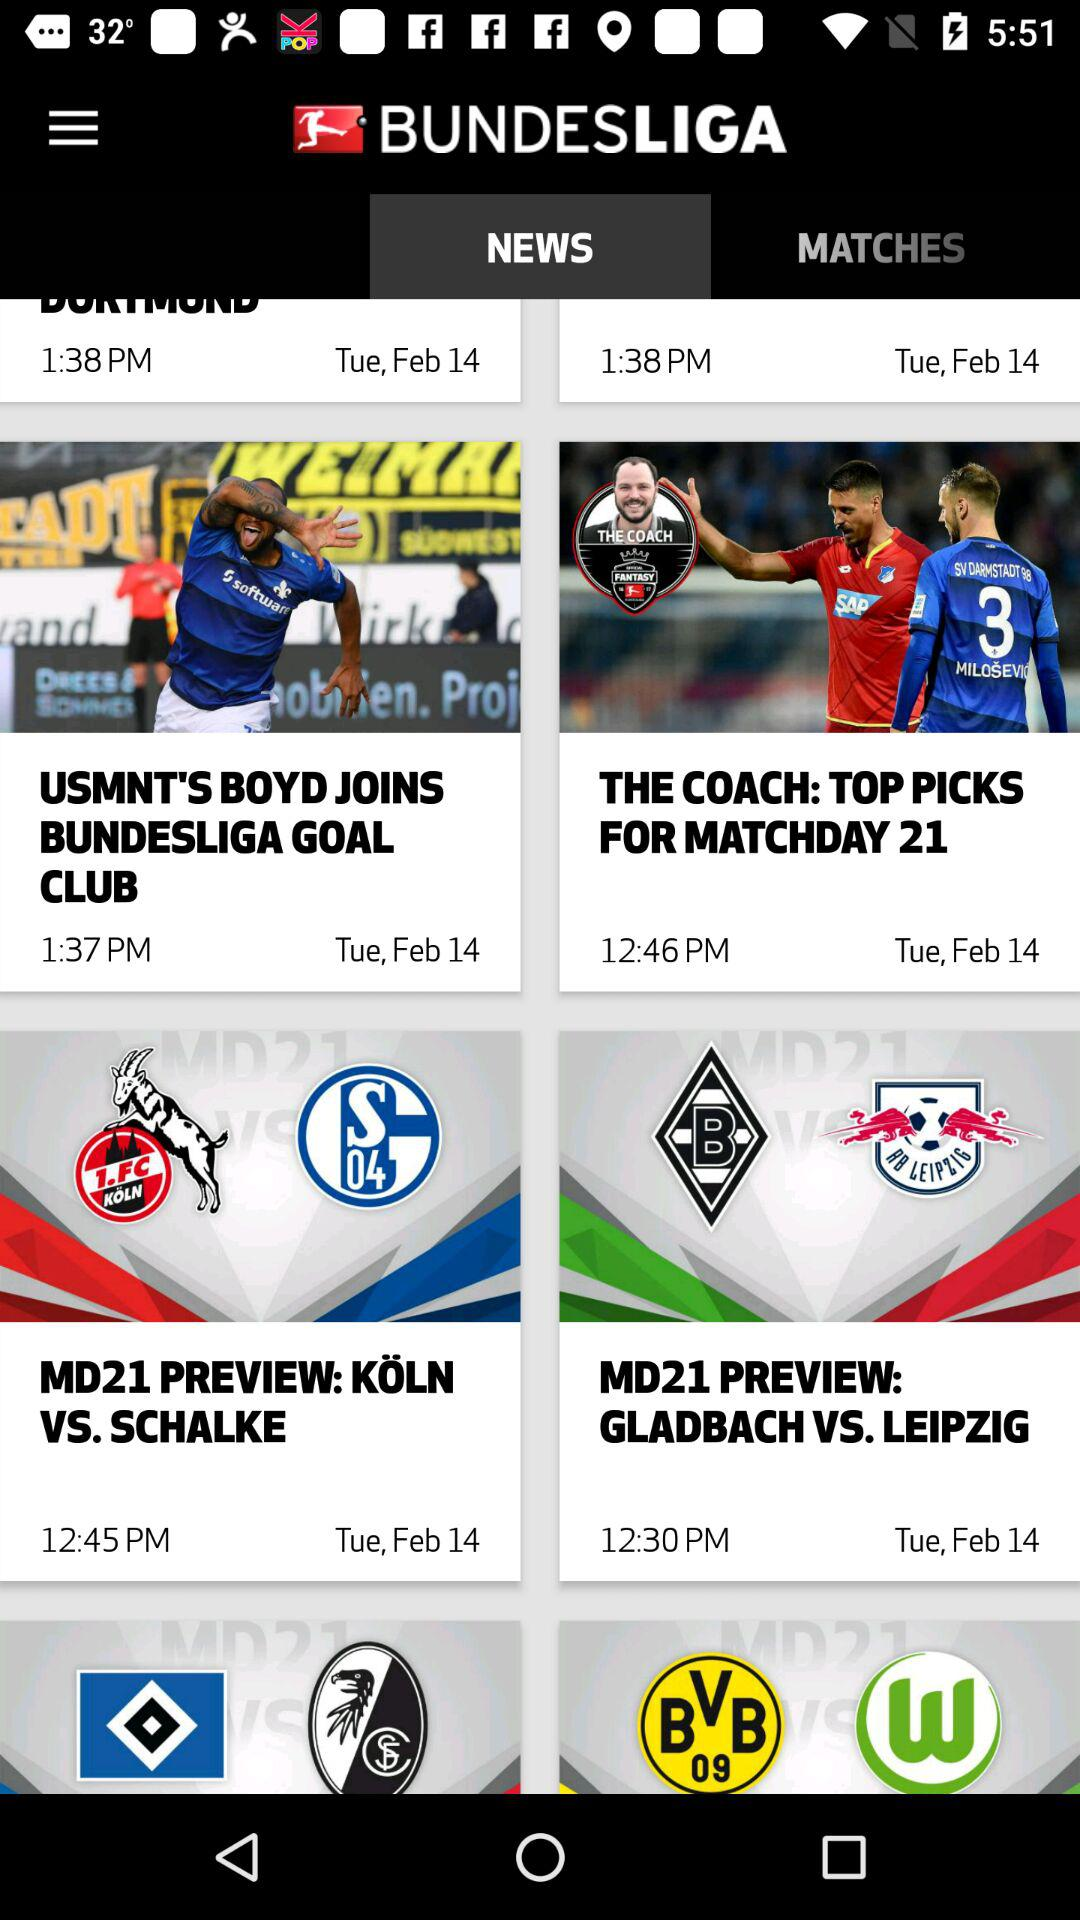At what date is the news "THE COACH: TOP PICKS FOR MATCHDAY 21" published? The news "THE COACH: TOP PICKS FOR MATCHDAY 21" is published on Tuesday, February 14. 